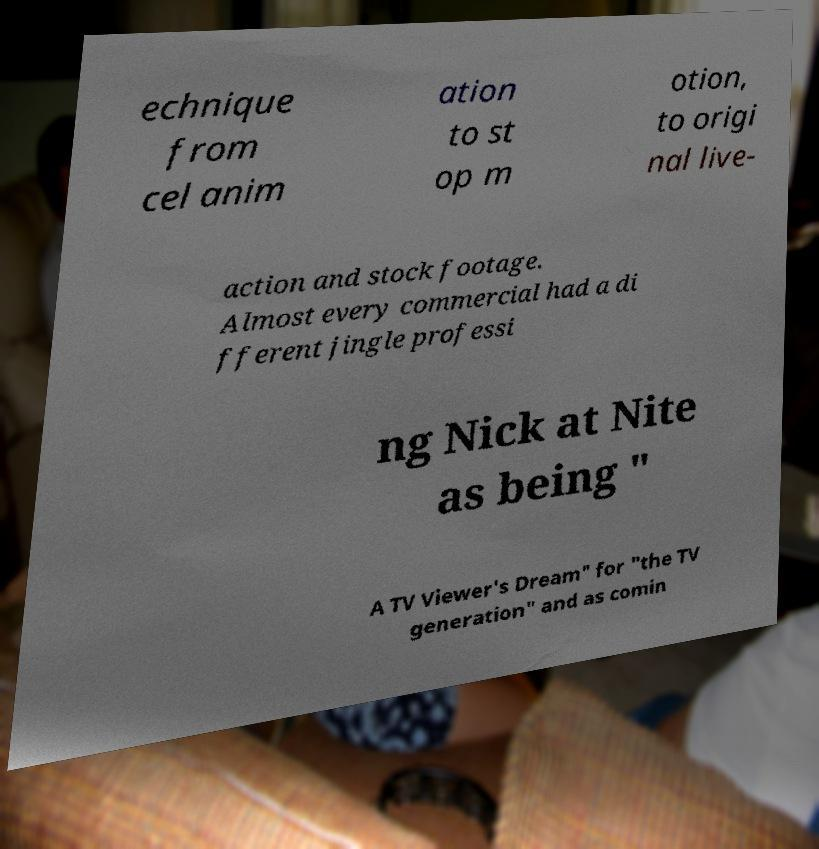Could you assist in decoding the text presented in this image and type it out clearly? echnique from cel anim ation to st op m otion, to origi nal live- action and stock footage. Almost every commercial had a di fferent jingle professi ng Nick at Nite as being " A TV Viewer's Dream" for "the TV generation" and as comin 